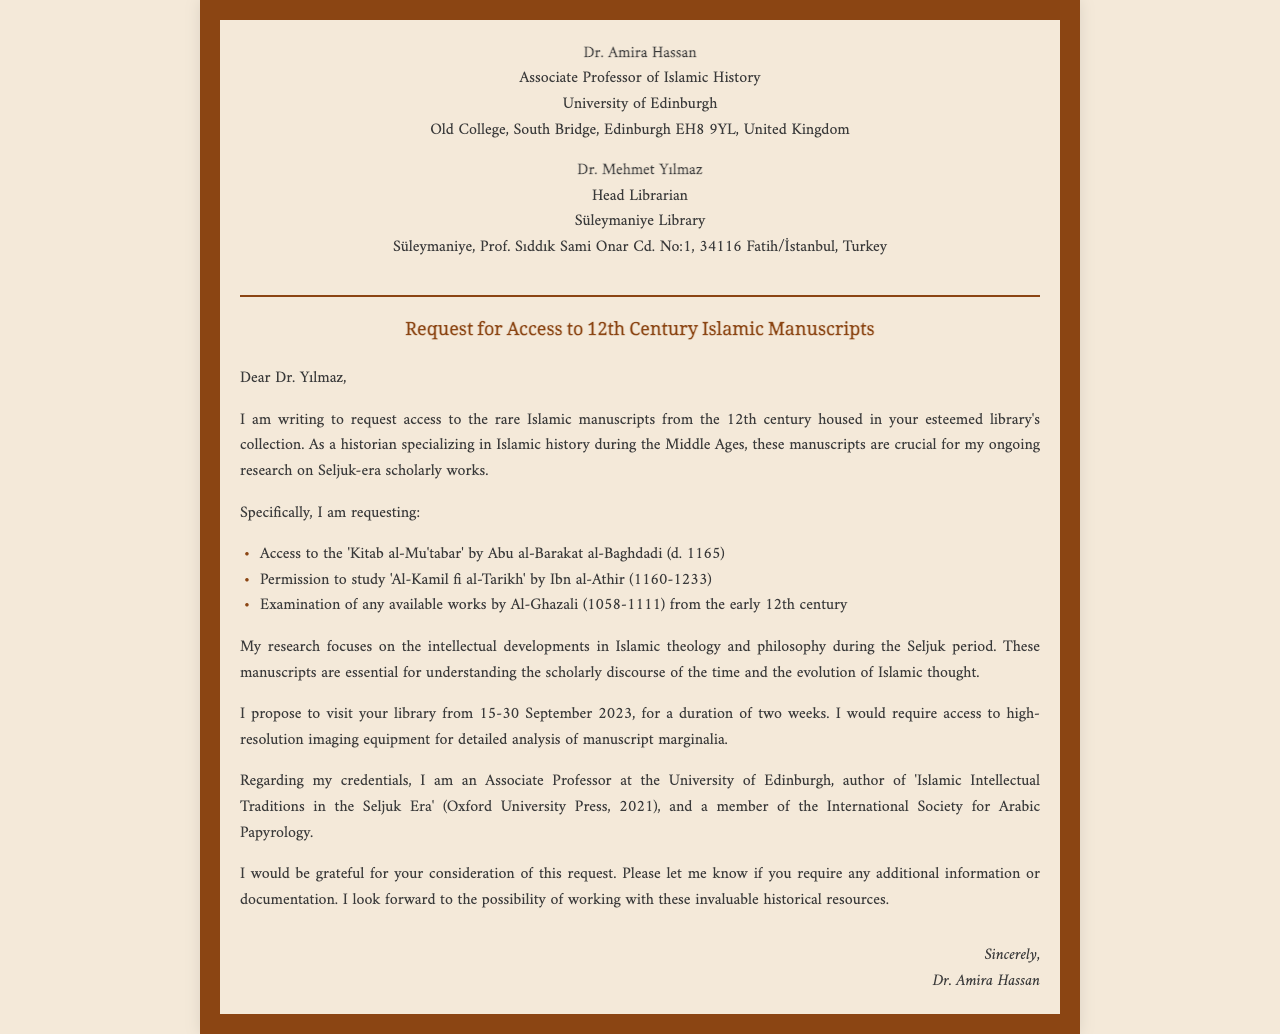What is the name of the sender? The sender is Dr. Amira Hassan, as stated at the beginning of the document.
Answer: Dr. Amira Hassan What is the title of the manuscript by Abu al-Barakat al-Baghdadi? The title of the manuscript is 'Kitab al-Mu'tabar', which is specifically mentioned in the list of requested works.
Answer: 'Kitab al-Mu'tabar' What is the proposed visit duration? Dr. Amira Hassan proposes to visit for two weeks, as indicated in the request.
Answer: two weeks What date does Dr. Amira propose to visit the library? The proposed visit starts on 15 September 2023, as mentioned in the content of the fax.
Answer: 15 September 2023 What is the research focus of Dr. Amira Hassan? The research focus is on intellectual developments in Islamic theology and philosophy during the Seljuk period, as outlined in the document.
Answer: Islamic theology and philosophy during the Seljuk period What is the position of Dr. Amira Hassan? Dr. Amira Hassan holds the position of Associate Professor, which is mentioned in her introduction.
Answer: Associate Professor How many manuscripts are specifically requested for access? There are three specific manuscripts requested, as indicated in the bullet points.
Answer: three What organization is Dr. Amira a member of? Dr. Amira is a member of the International Society for Arabic Papyrology, which is noted in the request.
Answer: International Society for Arabic Papyrology 